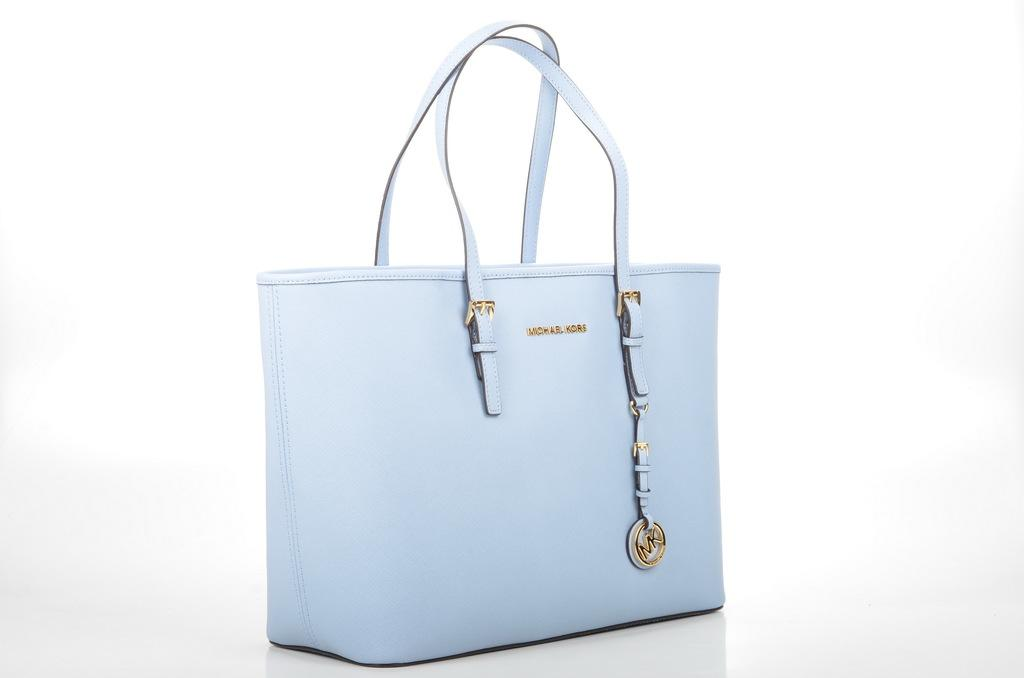What object is present in the image that can be used for carrying items? There is a bag in the image that can be used for carrying items. What color is the bag in the image? The bag is blue in color. Is there any text visible on the bag in the image? Yes, there is text on the bag in the image. What type of pan is being used to cook food in the image? There is no pan present in the image; it only features a blue bag with text on it. 